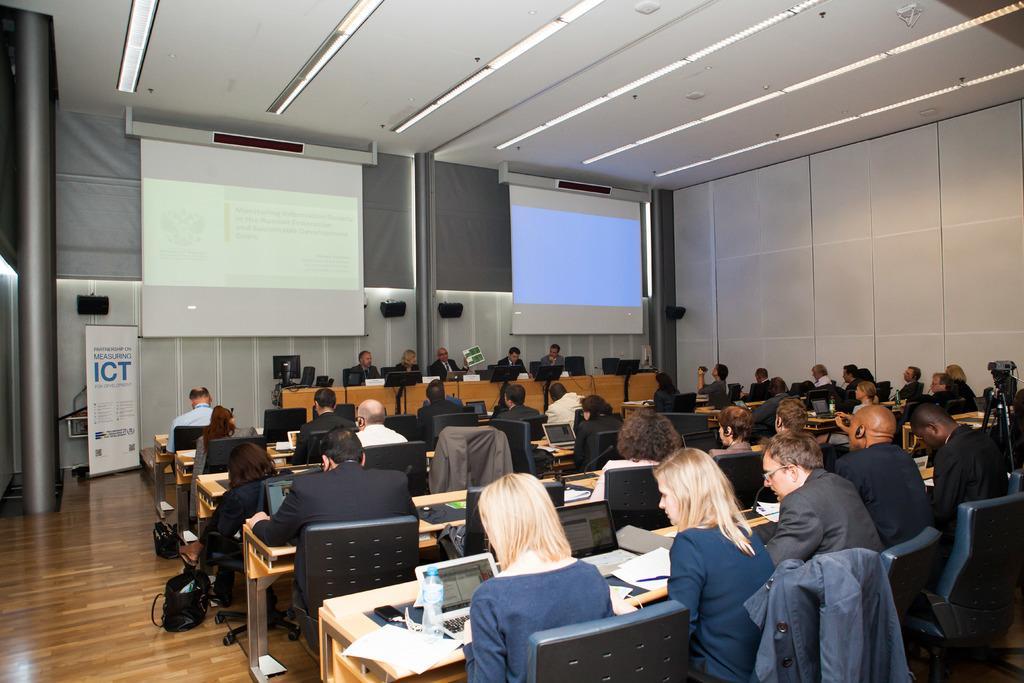Please provide a concise description of this image. In this image there are a group of people who are sitting on chairs, in front of them there are some tables. On the tables there are laptops, bottles, papers and some objects, and at the bottom there is floor. On the floor there are some bags, and in the background there are two screens and some persons are sitting. On the right side there is a wall, on the left side there is a pole and board. On the board there is text and in the background there is wall. At the top there is ceiling and some lights. 